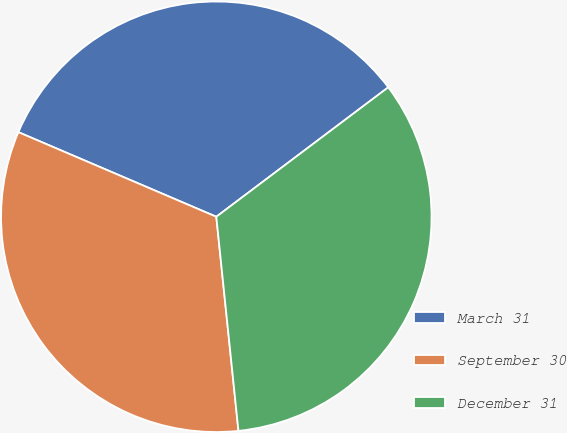Convert chart to OTSL. <chart><loc_0><loc_0><loc_500><loc_500><pie_chart><fcel>March 31<fcel>September 30<fcel>December 31<nl><fcel>33.3%<fcel>33.07%<fcel>33.63%<nl></chart> 